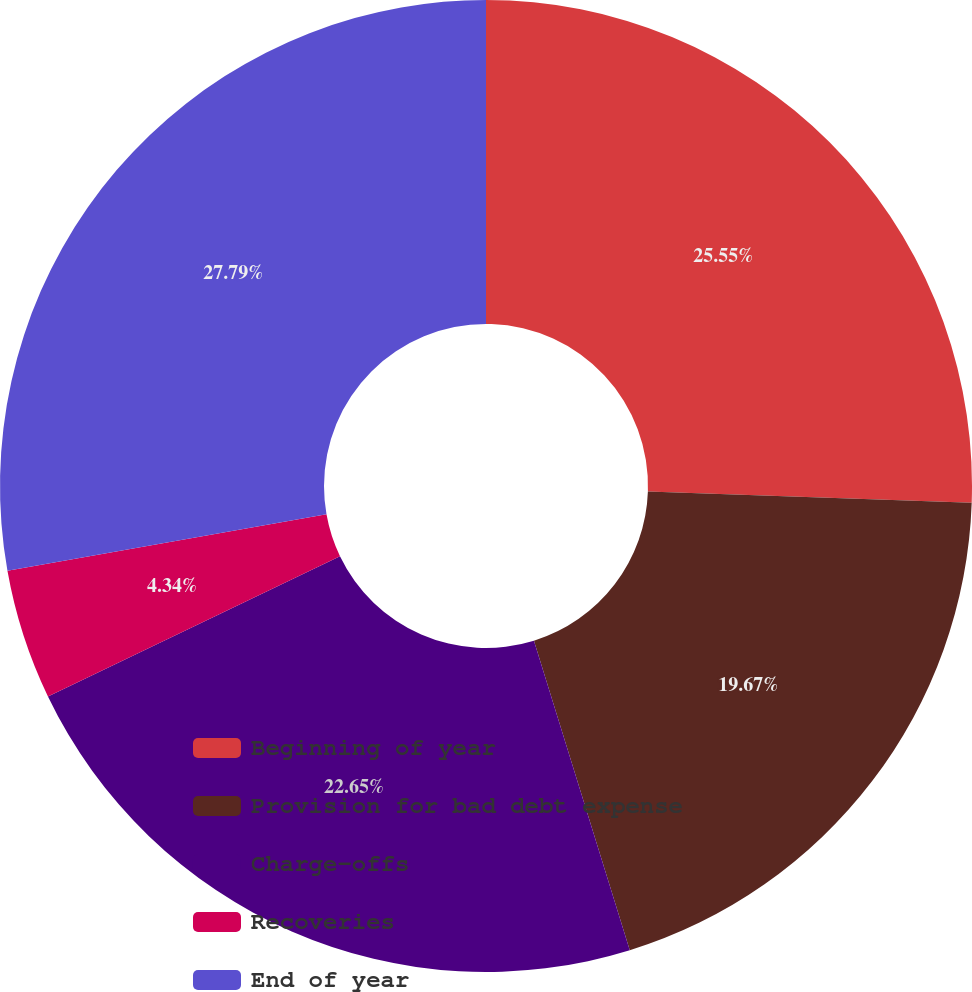<chart> <loc_0><loc_0><loc_500><loc_500><pie_chart><fcel>Beginning of year<fcel>Provision for bad debt expense<fcel>Charge-offs<fcel>Recoveries<fcel>End of year<nl><fcel>25.55%<fcel>19.67%<fcel>22.65%<fcel>4.34%<fcel>27.79%<nl></chart> 